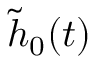Convert formula to latex. <formula><loc_0><loc_0><loc_500><loc_500>\tilde { h } _ { 0 } ( t )</formula> 